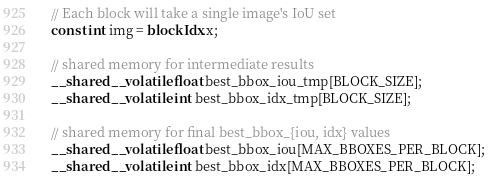Convert code to text. <code><loc_0><loc_0><loc_500><loc_500><_Cuda_>
  // Each block will take a single image's IoU set
  const int img = blockIdx.x;

  // shared memory for intermediate results
  __shared__ volatile float best_bbox_iou_tmp[BLOCK_SIZE];
  __shared__ volatile int best_bbox_idx_tmp[BLOCK_SIZE];

  // shared memory for final best_bbox_{iou, idx} values
  __shared__ volatile float best_bbox_iou[MAX_BBOXES_PER_BLOCK];
  __shared__ volatile int best_bbox_idx[MAX_BBOXES_PER_BLOCK];
</code> 